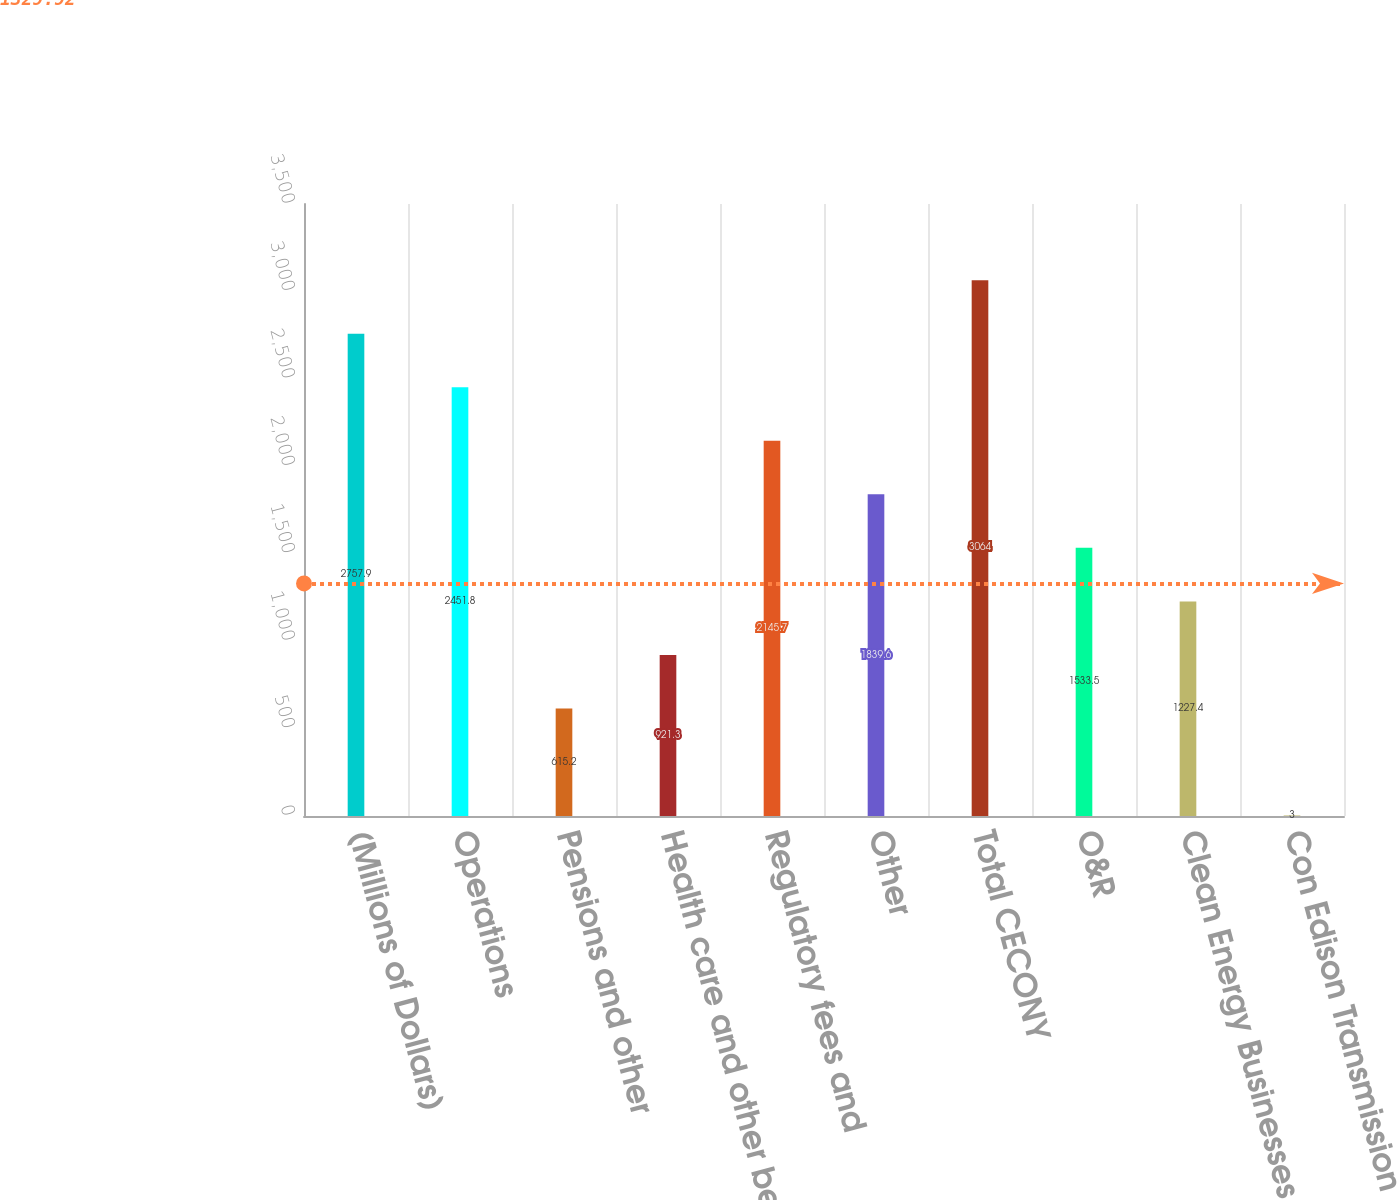<chart> <loc_0><loc_0><loc_500><loc_500><bar_chart><fcel>(Millions of Dollars)<fcel>Operations<fcel>Pensions and other<fcel>Health care and other benefits<fcel>Regulatory fees and<fcel>Other<fcel>Total CECONY<fcel>O&R<fcel>Clean Energy Businesses (b)<fcel>Con Edison Transmission<nl><fcel>2757.9<fcel>2451.8<fcel>615.2<fcel>921.3<fcel>2145.7<fcel>1839.6<fcel>3064<fcel>1533.5<fcel>1227.4<fcel>3<nl></chart> 